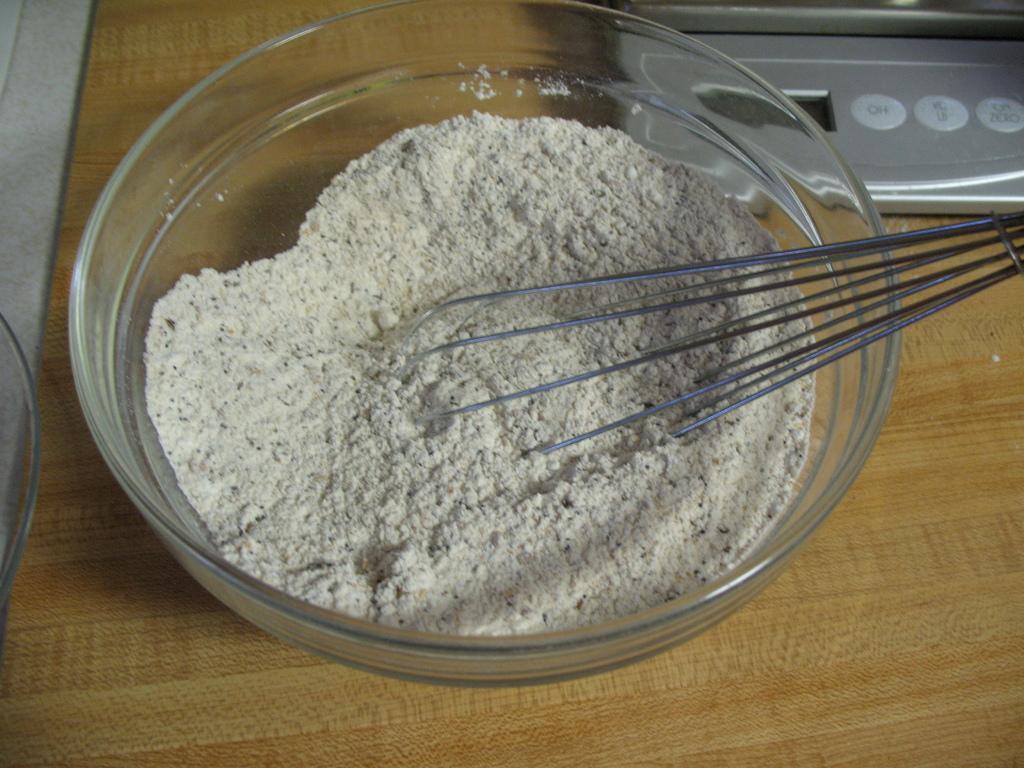Please provide a concise description of this image. In this picture we can see the glass bowl full of wheat flour with whisk is placed on the a wooden table top. 